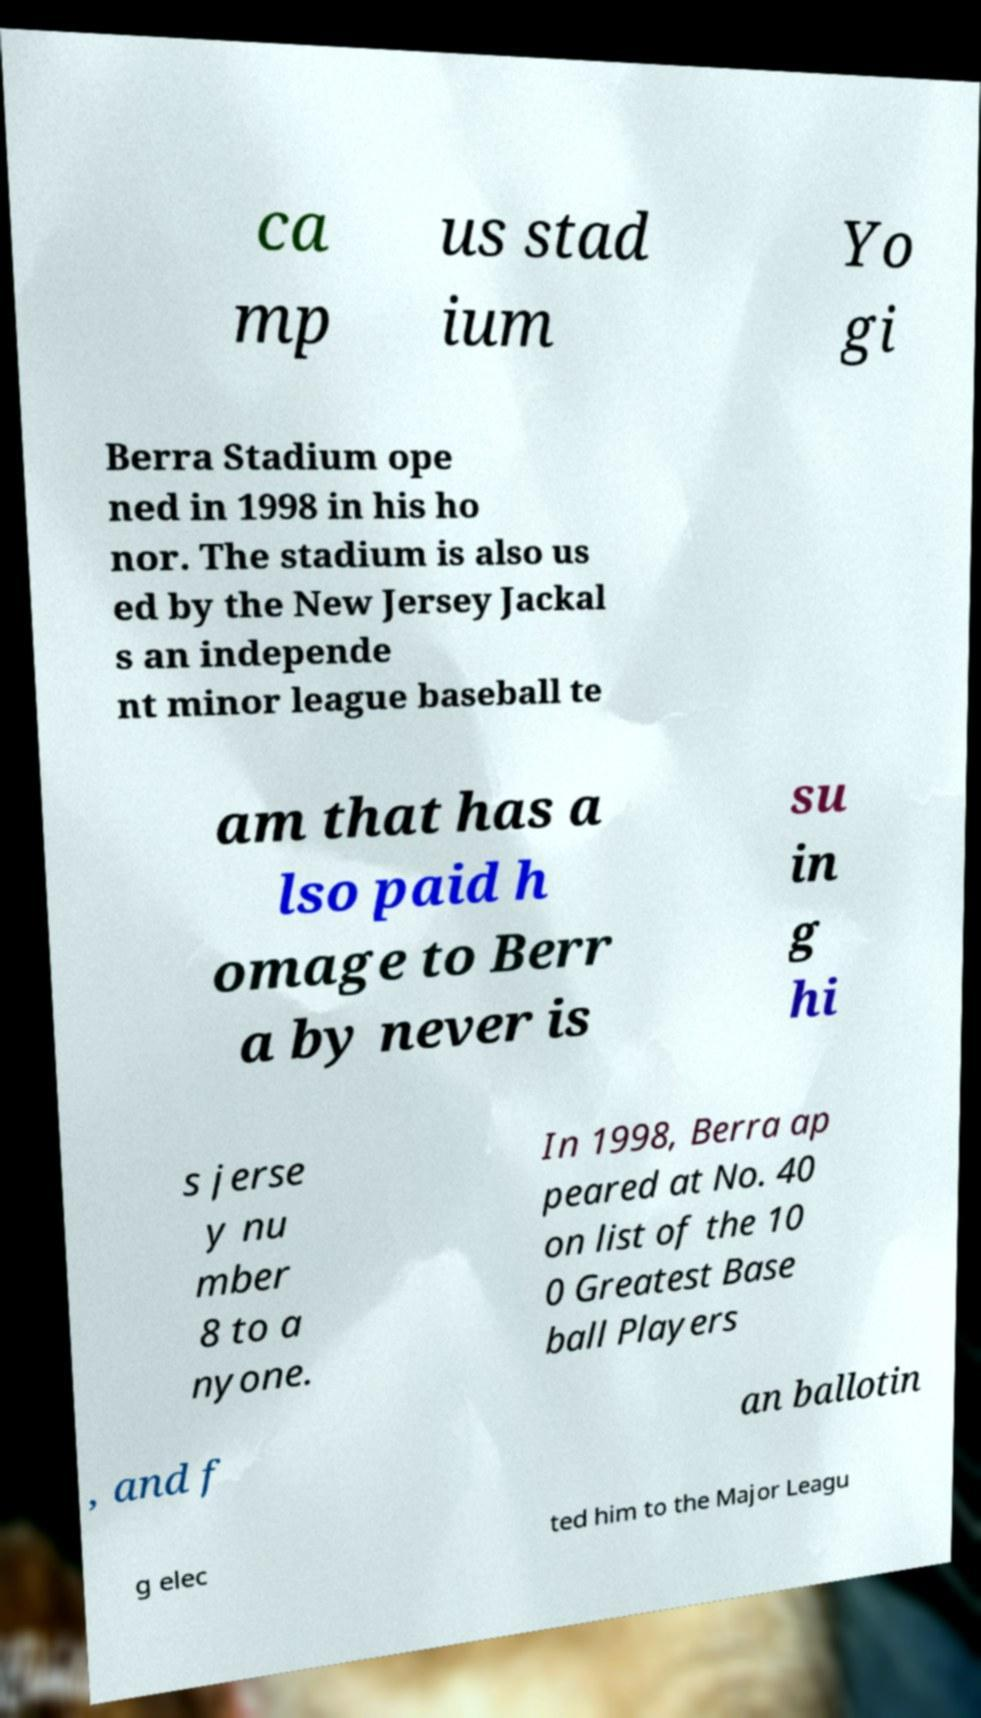What messages or text are displayed in this image? I need them in a readable, typed format. ca mp us stad ium Yo gi Berra Stadium ope ned in 1998 in his ho nor. The stadium is also us ed by the New Jersey Jackal s an independe nt minor league baseball te am that has a lso paid h omage to Berr a by never is su in g hi s jerse y nu mber 8 to a nyone. In 1998, Berra ap peared at No. 40 on list of the 10 0 Greatest Base ball Players , and f an ballotin g elec ted him to the Major Leagu 